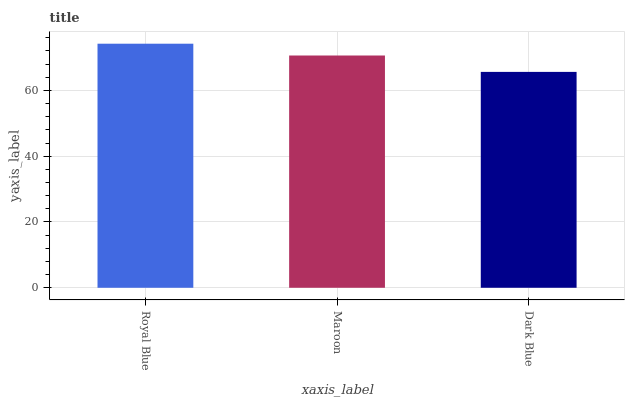Is Maroon the minimum?
Answer yes or no. No. Is Maroon the maximum?
Answer yes or no. No. Is Royal Blue greater than Maroon?
Answer yes or no. Yes. Is Maroon less than Royal Blue?
Answer yes or no. Yes. Is Maroon greater than Royal Blue?
Answer yes or no. No. Is Royal Blue less than Maroon?
Answer yes or no. No. Is Maroon the high median?
Answer yes or no. Yes. Is Maroon the low median?
Answer yes or no. Yes. Is Dark Blue the high median?
Answer yes or no. No. Is Royal Blue the low median?
Answer yes or no. No. 